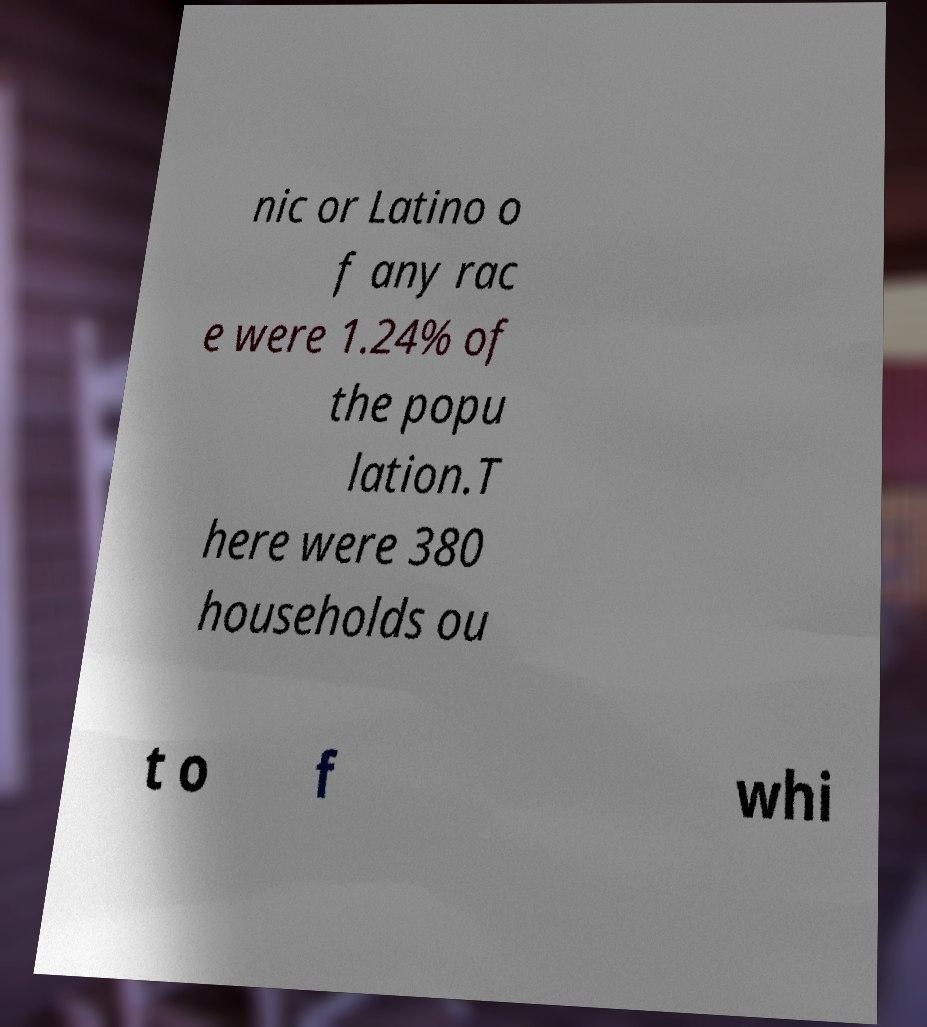Please read and relay the text visible in this image. What does it say? nic or Latino o f any rac e were 1.24% of the popu lation.T here were 380 households ou t o f whi 